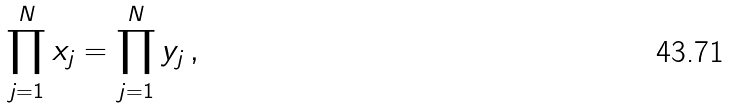Convert formula to latex. <formula><loc_0><loc_0><loc_500><loc_500>\prod _ { j = 1 } ^ { N } x _ { j } = \prod _ { j = 1 } ^ { N } y _ { j } \, ,</formula> 